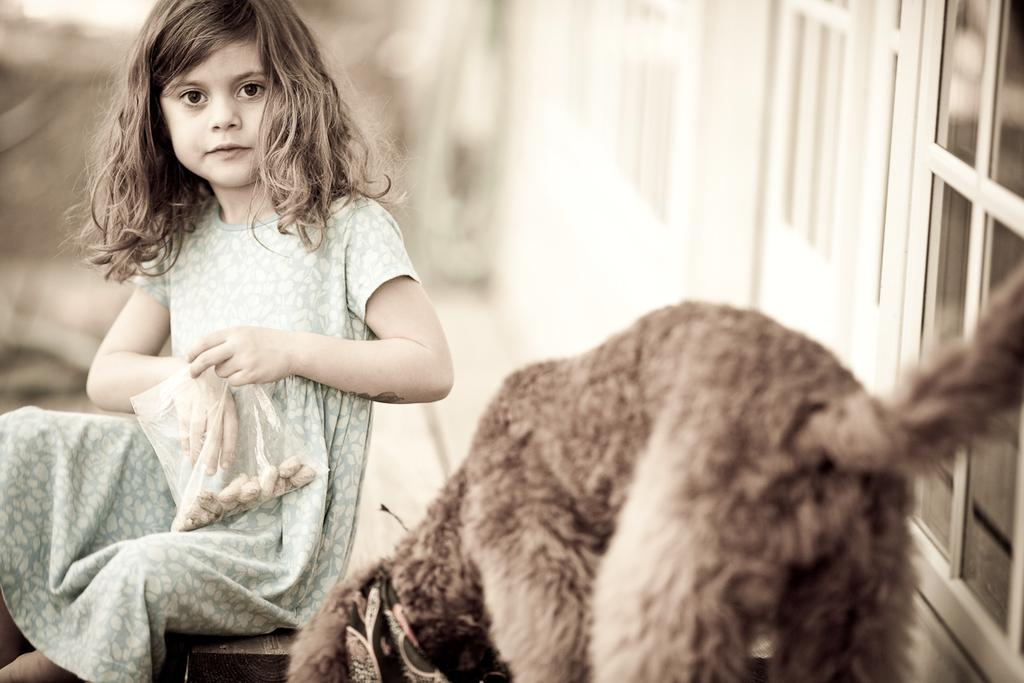What is the girl in the image doing? The girl is sitting on the floor in the image. What is the girl holding in her hand? The girl is holding a packet in the image. What animal is in front of the girl? There is a dog in front of the girl in the image. What can be seen in the distance behind the girl? There is a building in the background of the image. What type of basket is the girl attempting to weave in the image? There is no basket present in the image, nor is there any indication that the girl is attempting to weave one. 